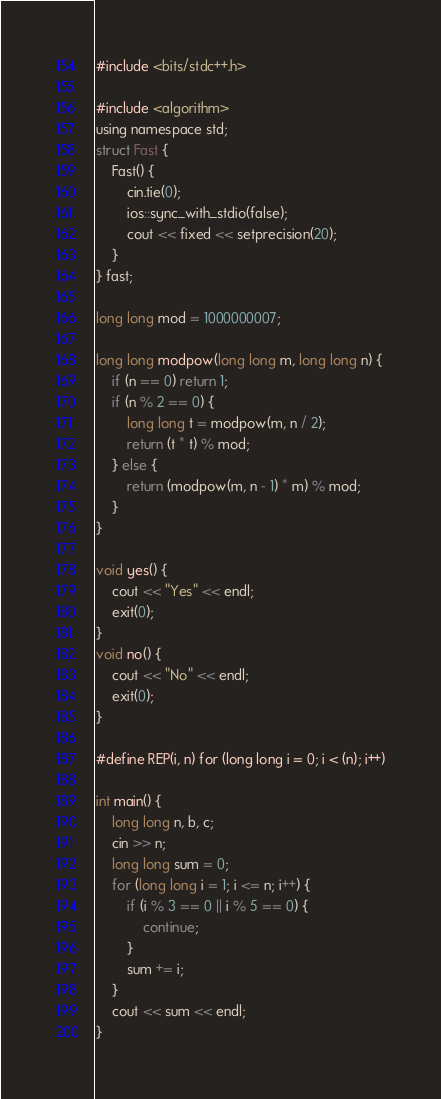Convert code to text. <code><loc_0><loc_0><loc_500><loc_500><_C_>#include <bits/stdc++.h>

#include <algorithm>
using namespace std;
struct Fast {
    Fast() {
        cin.tie(0);
        ios::sync_with_stdio(false);
        cout << fixed << setprecision(20);
    }
} fast;

long long mod = 1000000007;

long long modpow(long long m, long long n) {
    if (n == 0) return 1;
    if (n % 2 == 0) {
        long long t = modpow(m, n / 2);
        return (t * t) % mod;
    } else {
        return (modpow(m, n - 1) * m) % mod;
    }
}

void yes() {
    cout << "Yes" << endl;
    exit(0);
}
void no() {
    cout << "No" << endl;
    exit(0);
}

#define REP(i, n) for (long long i = 0; i < (n); i++)

int main() {
    long long n, b, c;
    cin >> n;
    long long sum = 0;
    for (long long i = 1; i <= n; i++) {
        if (i % 3 == 0 || i % 5 == 0) {
            continue;
        }
        sum += i;
    }
    cout << sum << endl;
}</code> 